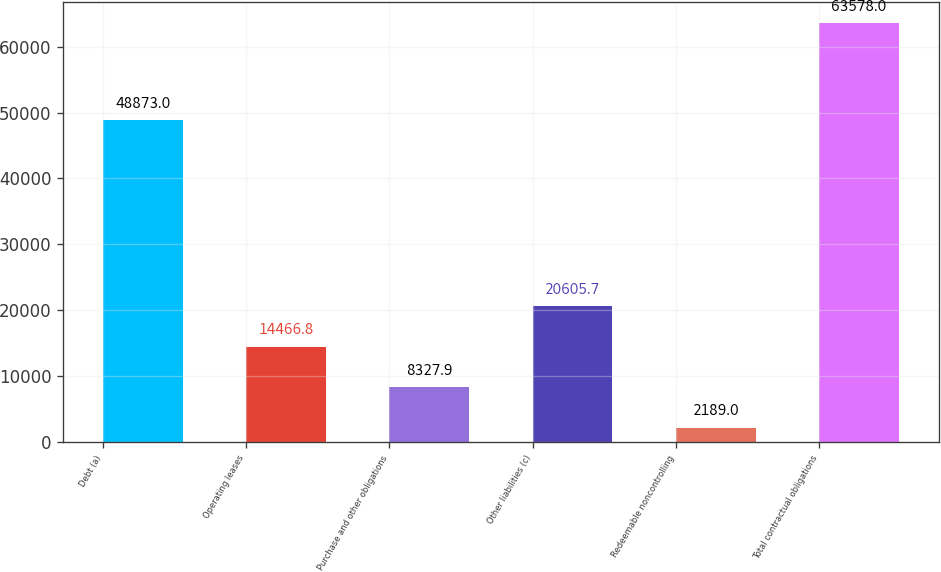Convert chart. <chart><loc_0><loc_0><loc_500><loc_500><bar_chart><fcel>Debt (a)<fcel>Operating leases<fcel>Purchase and other obligations<fcel>Other liabilities (c)<fcel>Redeemable noncontrolling<fcel>Total contractual obligations<nl><fcel>48873<fcel>14466.8<fcel>8327.9<fcel>20605.7<fcel>2189<fcel>63578<nl></chart> 